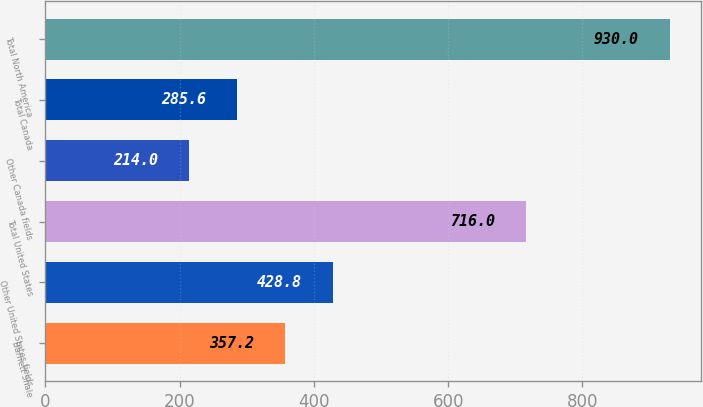Convert chart to OTSL. <chart><loc_0><loc_0><loc_500><loc_500><bar_chart><fcel>Barnett Shale<fcel>Other United States fields<fcel>Total United States<fcel>Other Canada fields<fcel>Total Canada<fcel>Total North America<nl><fcel>357.2<fcel>428.8<fcel>716<fcel>214<fcel>285.6<fcel>930<nl></chart> 